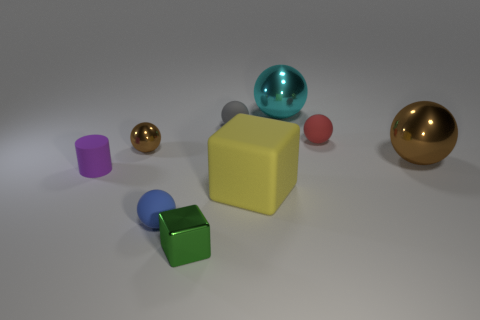There is a brown metallic ball on the right side of the big yellow object to the right of the small gray object; what is its size?
Keep it short and to the point. Large. What is the shape of the matte thing that is behind the tiny purple cylinder and in front of the gray matte object?
Make the answer very short. Sphere. What is the color of the small metallic object that is the same shape as the tiny red rubber object?
Your answer should be compact. Brown. The large metallic object that is the same color as the small metal sphere is what shape?
Keep it short and to the point. Sphere. There is another shiny object that is the same size as the cyan object; what is its color?
Your response must be concise. Brown. Are there any big metallic things that have the same color as the small metal ball?
Your answer should be very brief. Yes. There is a tiny gray matte thing on the left side of the large yellow matte thing; is its shape the same as the big object that is on the left side of the large cyan shiny object?
Your response must be concise. No. There is another sphere that is the same color as the tiny metal ball; what is its size?
Provide a succinct answer. Large. There is a tiny metallic ball; does it have the same color as the metal ball right of the tiny red sphere?
Your response must be concise. Yes. The metal ball that is both in front of the cyan ball and to the right of the blue sphere is what color?
Give a very brief answer. Brown. 